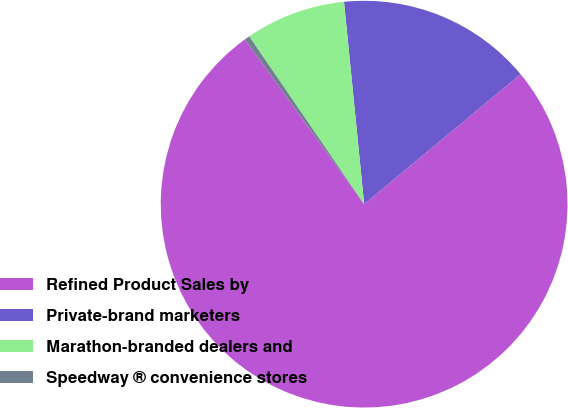Convert chart. <chart><loc_0><loc_0><loc_500><loc_500><pie_chart><fcel>Refined Product Sales by<fcel>Private-brand marketers<fcel>Marathon-branded dealers and<fcel>Speedway ® convenience stores<nl><fcel>76.06%<fcel>15.54%<fcel>7.98%<fcel>0.42%<nl></chart> 